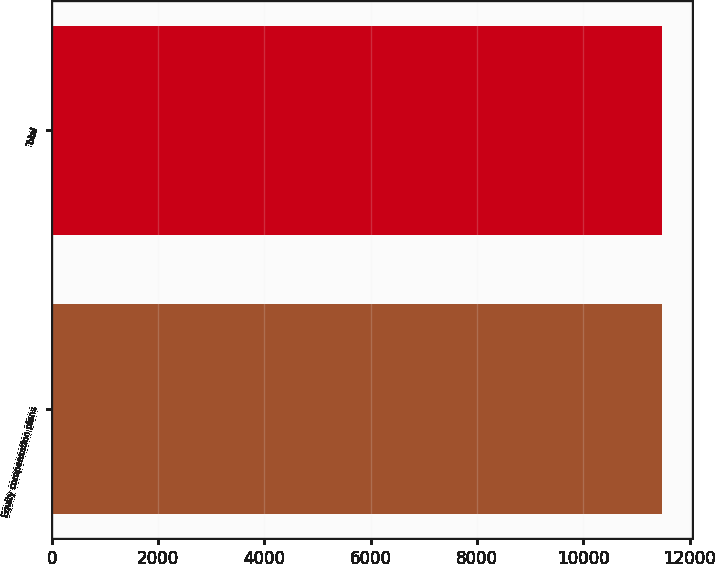<chart> <loc_0><loc_0><loc_500><loc_500><bar_chart><fcel>Equity compensation plans<fcel>Total<nl><fcel>11476<fcel>11476.1<nl></chart> 